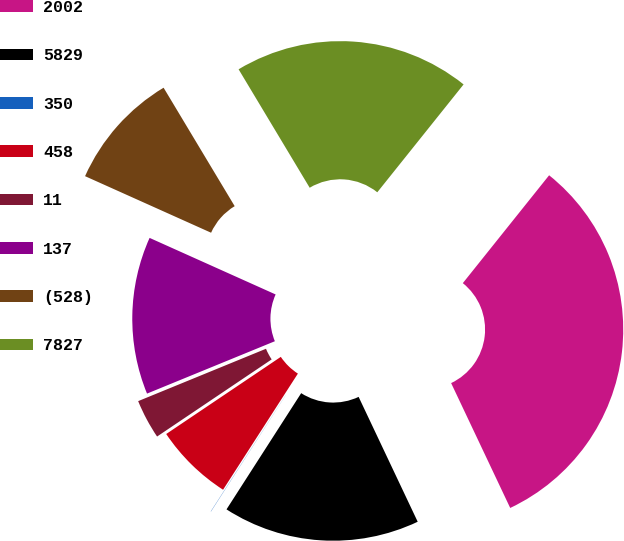<chart> <loc_0><loc_0><loc_500><loc_500><pie_chart><fcel>2002<fcel>5829<fcel>350<fcel>458<fcel>11<fcel>137<fcel>(528)<fcel>7827<nl><fcel>32.22%<fcel>16.12%<fcel>0.02%<fcel>6.46%<fcel>3.24%<fcel>12.9%<fcel>9.68%<fcel>19.34%<nl></chart> 